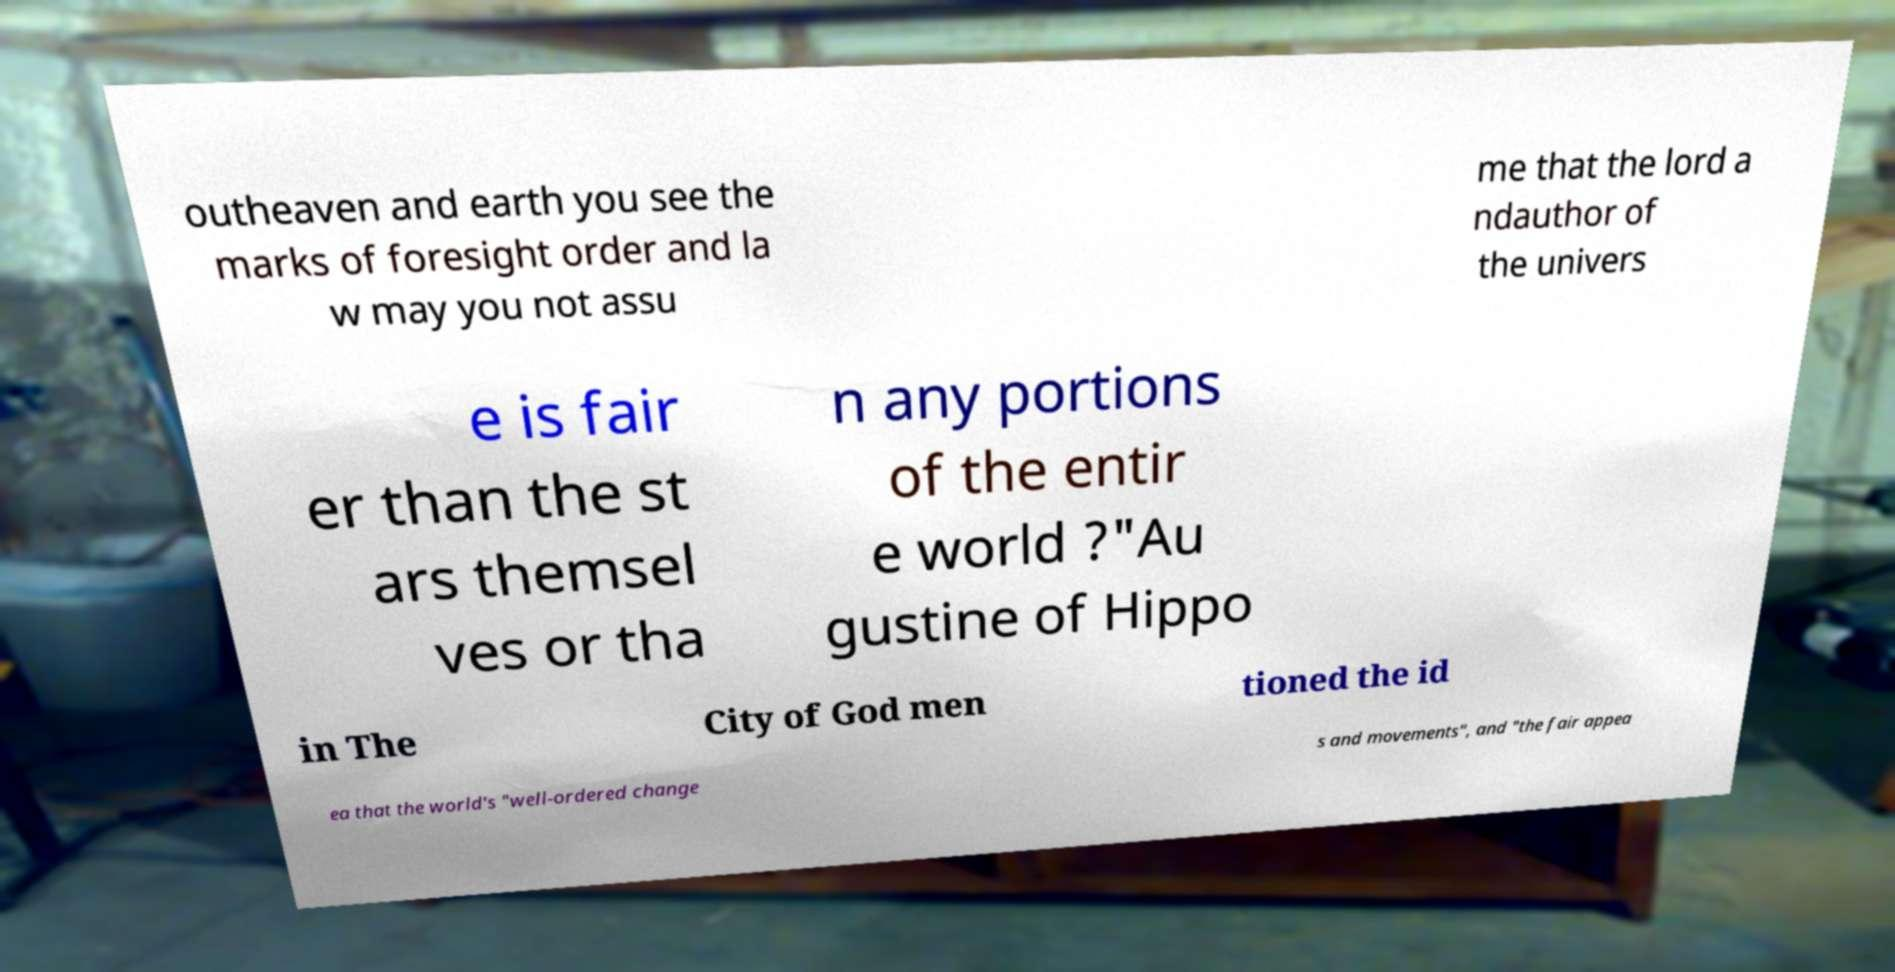There's text embedded in this image that I need extracted. Can you transcribe it verbatim? outheaven and earth you see the marks of foresight order and la w may you not assu me that the lord a ndauthor of the univers e is fair er than the st ars themsel ves or tha n any portions of the entir e world ?"Au gustine of Hippo in The City of God men tioned the id ea that the world's "well-ordered change s and movements", and "the fair appea 